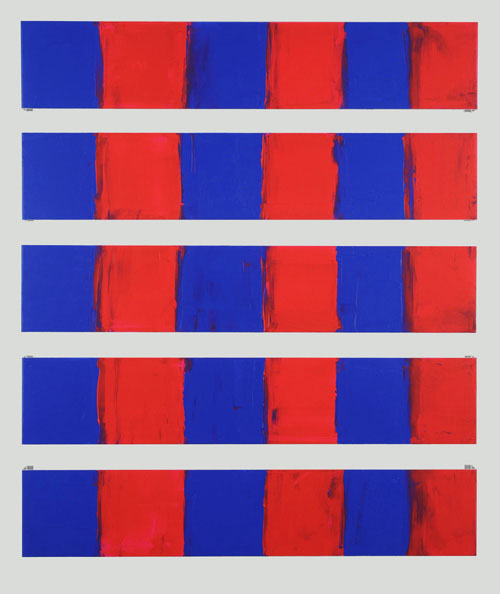Can you describe the mood conveyed by this artwork? The artwork evokes a vibrant and intense mood through its use of bold, contrasting colors. The juxtaposition of red and blue creates a striking visual tension, which may stir strong emotions in the viewer. The repetitive pattern introduces a sense of order and rhythm, balancing the intense energy with a structured calmness. This duality in mood can lead to various interpretations, depending on the viewer's perspective. 